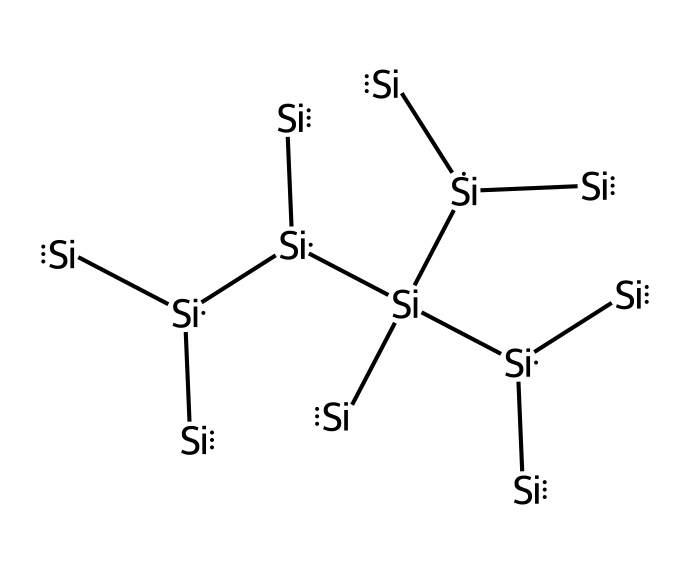What is the central atom in this structure? The structure displays multiple silicon atoms, and silicon ([Si]) constitutes the primary element throughout the entire molecular arrangement.
Answer: silicon How many silicon atoms are present in this molecule? By counting the silicon representations in the structure, there are a total of ten silicon atoms indicated.
Answer: ten What type of bonding is predominantly present in this silicon structure? The arrangement primarily involves covalent bonding between the silicon atoms, which is characteristic for this type of structure in silicon.
Answer: covalent Does this structure suggest any three-dimensional arrangement? The complex structure suggests a three-dimensional arrangement due to the branching and interconnected nature of the silicon atoms which can lead to a three-dimensional network.
Answer: yes What is the implication of silicon's structure for its use in solar panels? The extensive network of silicon atoms contributes to its semiconductor properties, enabling efficient absorption and conversion of sunlight into energy, which is crucial for solar panel functionality.
Answer: efficiency What major chemical property is influenced by the arrangement of silicon atoms in this structure? The arrangement influences conductivity, as the network of silicon allows for effective charge transport necessary for electrical applications in solar panels.
Answer: conductivity 